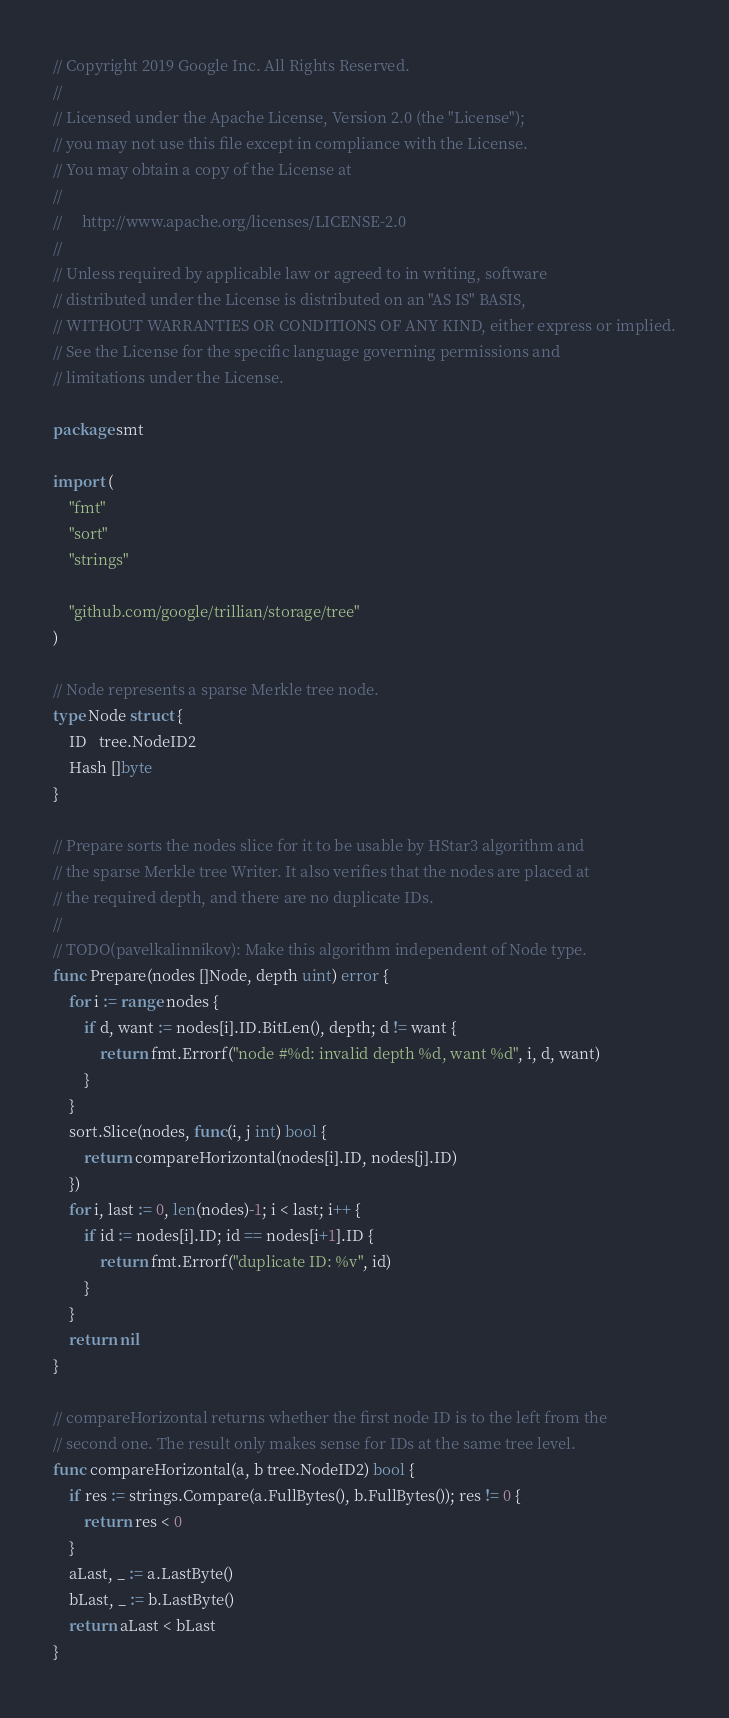Convert code to text. <code><loc_0><loc_0><loc_500><loc_500><_Go_>// Copyright 2019 Google Inc. All Rights Reserved.
//
// Licensed under the Apache License, Version 2.0 (the "License");
// you may not use this file except in compliance with the License.
// You may obtain a copy of the License at
//
//     http://www.apache.org/licenses/LICENSE-2.0
//
// Unless required by applicable law or agreed to in writing, software
// distributed under the License is distributed on an "AS IS" BASIS,
// WITHOUT WARRANTIES OR CONDITIONS OF ANY KIND, either express or implied.
// See the License for the specific language governing permissions and
// limitations under the License.

package smt

import (
	"fmt"
	"sort"
	"strings"

	"github.com/google/trillian/storage/tree"
)

// Node represents a sparse Merkle tree node.
type Node struct {
	ID   tree.NodeID2
	Hash []byte
}

// Prepare sorts the nodes slice for it to be usable by HStar3 algorithm and
// the sparse Merkle tree Writer. It also verifies that the nodes are placed at
// the required depth, and there are no duplicate IDs.
//
// TODO(pavelkalinnikov): Make this algorithm independent of Node type.
func Prepare(nodes []Node, depth uint) error {
	for i := range nodes {
		if d, want := nodes[i].ID.BitLen(), depth; d != want {
			return fmt.Errorf("node #%d: invalid depth %d, want %d", i, d, want)
		}
	}
	sort.Slice(nodes, func(i, j int) bool {
		return compareHorizontal(nodes[i].ID, nodes[j].ID)
	})
	for i, last := 0, len(nodes)-1; i < last; i++ {
		if id := nodes[i].ID; id == nodes[i+1].ID {
			return fmt.Errorf("duplicate ID: %v", id)
		}
	}
	return nil
}

// compareHorizontal returns whether the first node ID is to the left from the
// second one. The result only makes sense for IDs at the same tree level.
func compareHorizontal(a, b tree.NodeID2) bool {
	if res := strings.Compare(a.FullBytes(), b.FullBytes()); res != 0 {
		return res < 0
	}
	aLast, _ := a.LastByte()
	bLast, _ := b.LastByte()
	return aLast < bLast
}
</code> 